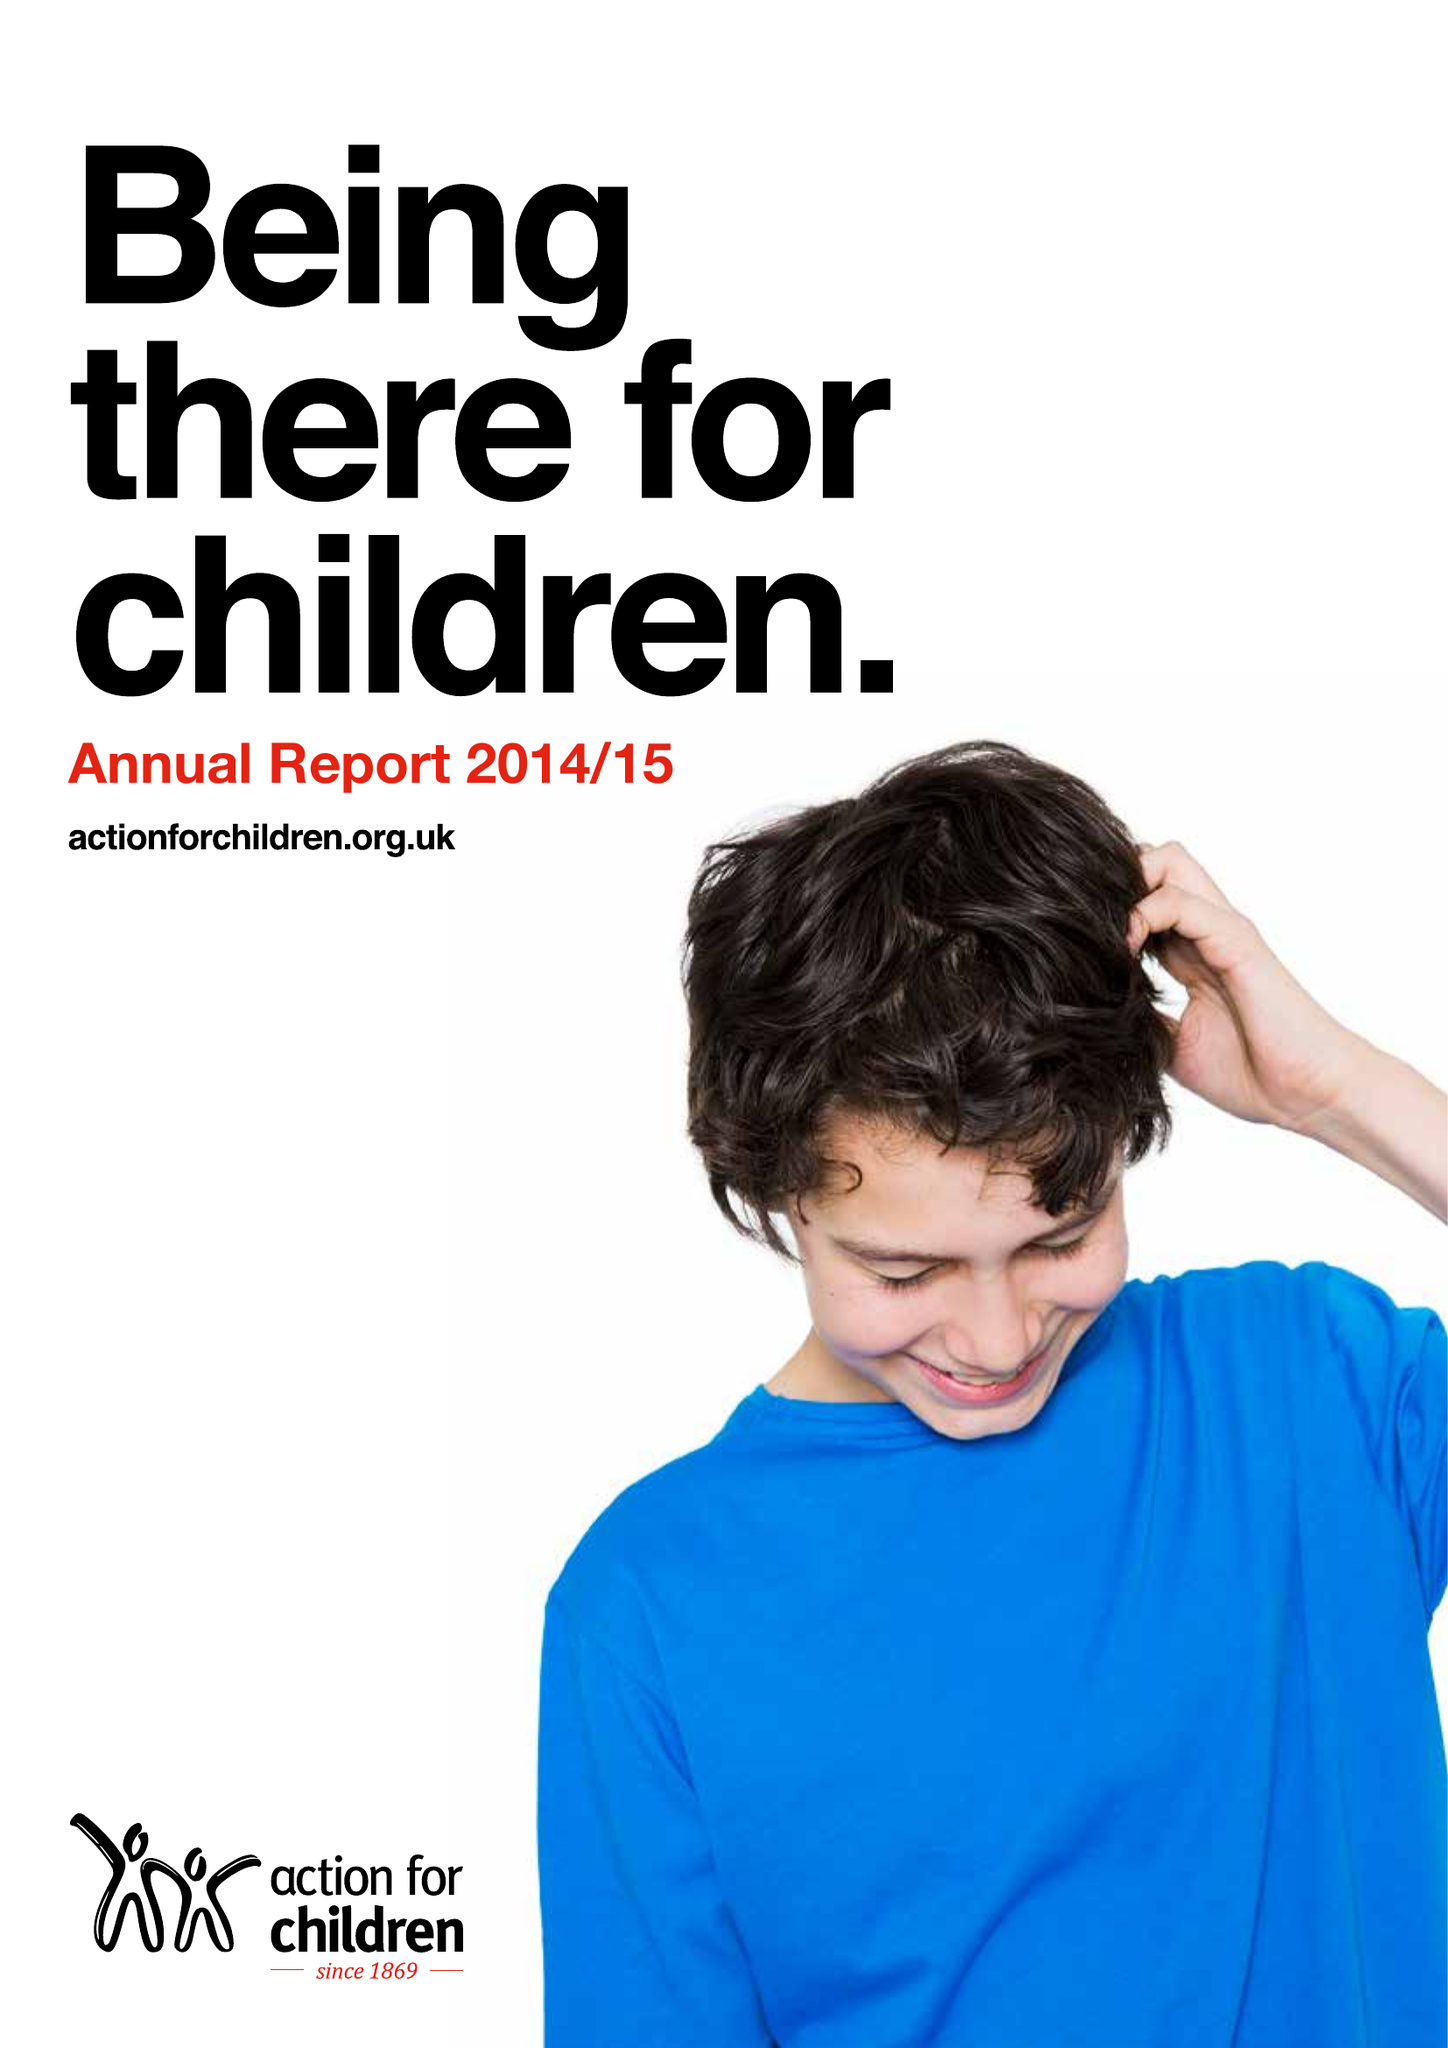What is the value for the address__post_town?
Answer the question using a single word or phrase. WATFORD 